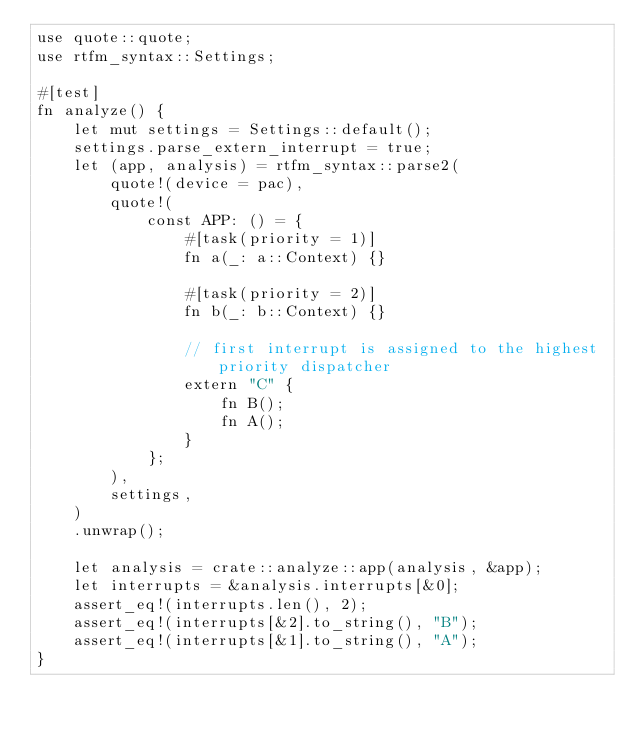Convert code to text. <code><loc_0><loc_0><loc_500><loc_500><_Rust_>use quote::quote;
use rtfm_syntax::Settings;

#[test]
fn analyze() {
    let mut settings = Settings::default();
    settings.parse_extern_interrupt = true;
    let (app, analysis) = rtfm_syntax::parse2(
        quote!(device = pac),
        quote!(
            const APP: () = {
                #[task(priority = 1)]
                fn a(_: a::Context) {}

                #[task(priority = 2)]
                fn b(_: b::Context) {}

                // first interrupt is assigned to the highest priority dispatcher
                extern "C" {
                    fn B();
                    fn A();
                }
            };
        ),
        settings,
    )
    .unwrap();

    let analysis = crate::analyze::app(analysis, &app);
    let interrupts = &analysis.interrupts[&0];
    assert_eq!(interrupts.len(), 2);
    assert_eq!(interrupts[&2].to_string(), "B");
    assert_eq!(interrupts[&1].to_string(), "A");
}
</code> 